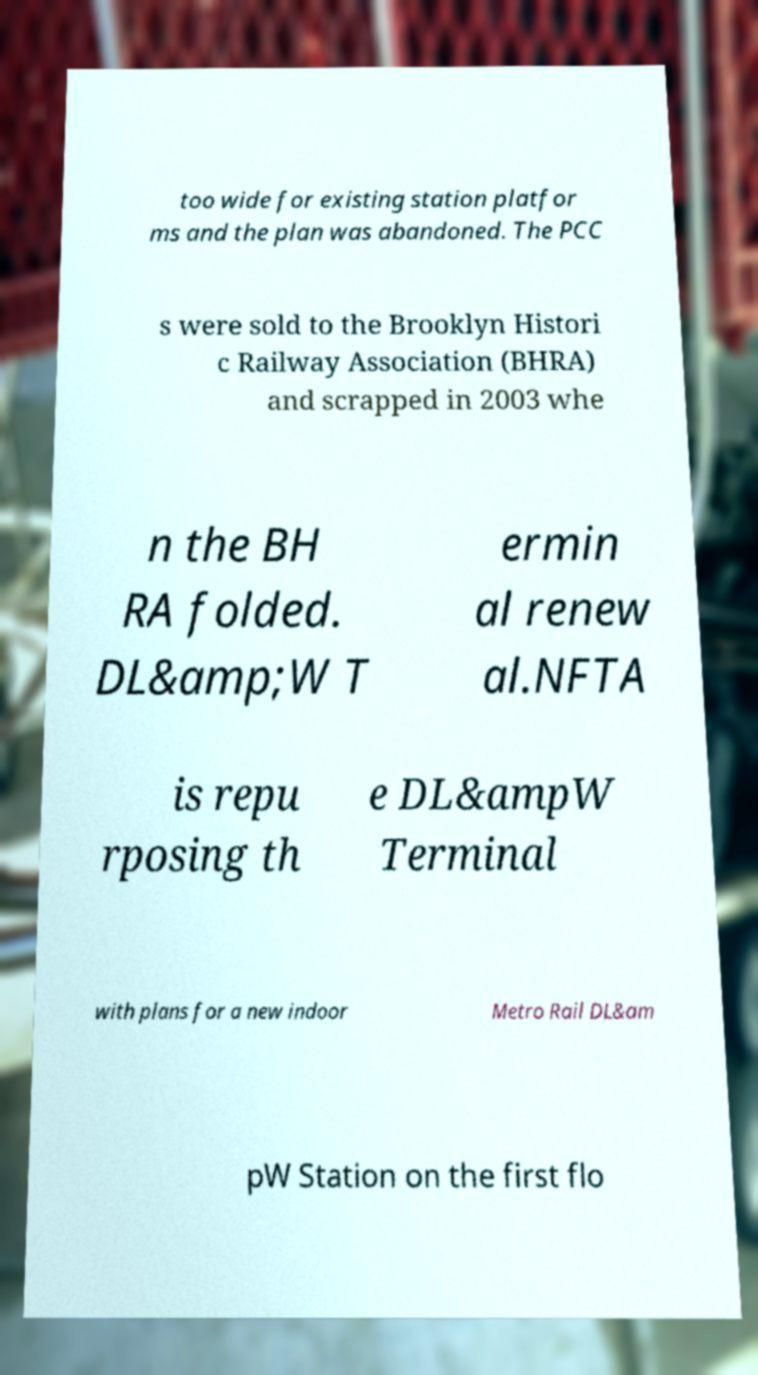Please read and relay the text visible in this image. What does it say? too wide for existing station platfor ms and the plan was abandoned. The PCC s were sold to the Brooklyn Histori c Railway Association (BHRA) and scrapped in 2003 whe n the BH RA folded. DL&amp;W T ermin al renew al.NFTA is repu rposing th e DL&ampW Terminal with plans for a new indoor Metro Rail DL&am pW Station on the first flo 